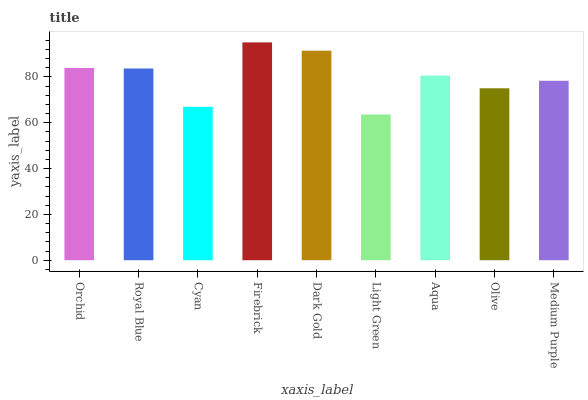Is Light Green the minimum?
Answer yes or no. Yes. Is Firebrick the maximum?
Answer yes or no. Yes. Is Royal Blue the minimum?
Answer yes or no. No. Is Royal Blue the maximum?
Answer yes or no. No. Is Orchid greater than Royal Blue?
Answer yes or no. Yes. Is Royal Blue less than Orchid?
Answer yes or no. Yes. Is Royal Blue greater than Orchid?
Answer yes or no. No. Is Orchid less than Royal Blue?
Answer yes or no. No. Is Aqua the high median?
Answer yes or no. Yes. Is Aqua the low median?
Answer yes or no. Yes. Is Medium Purple the high median?
Answer yes or no. No. Is Light Green the low median?
Answer yes or no. No. 